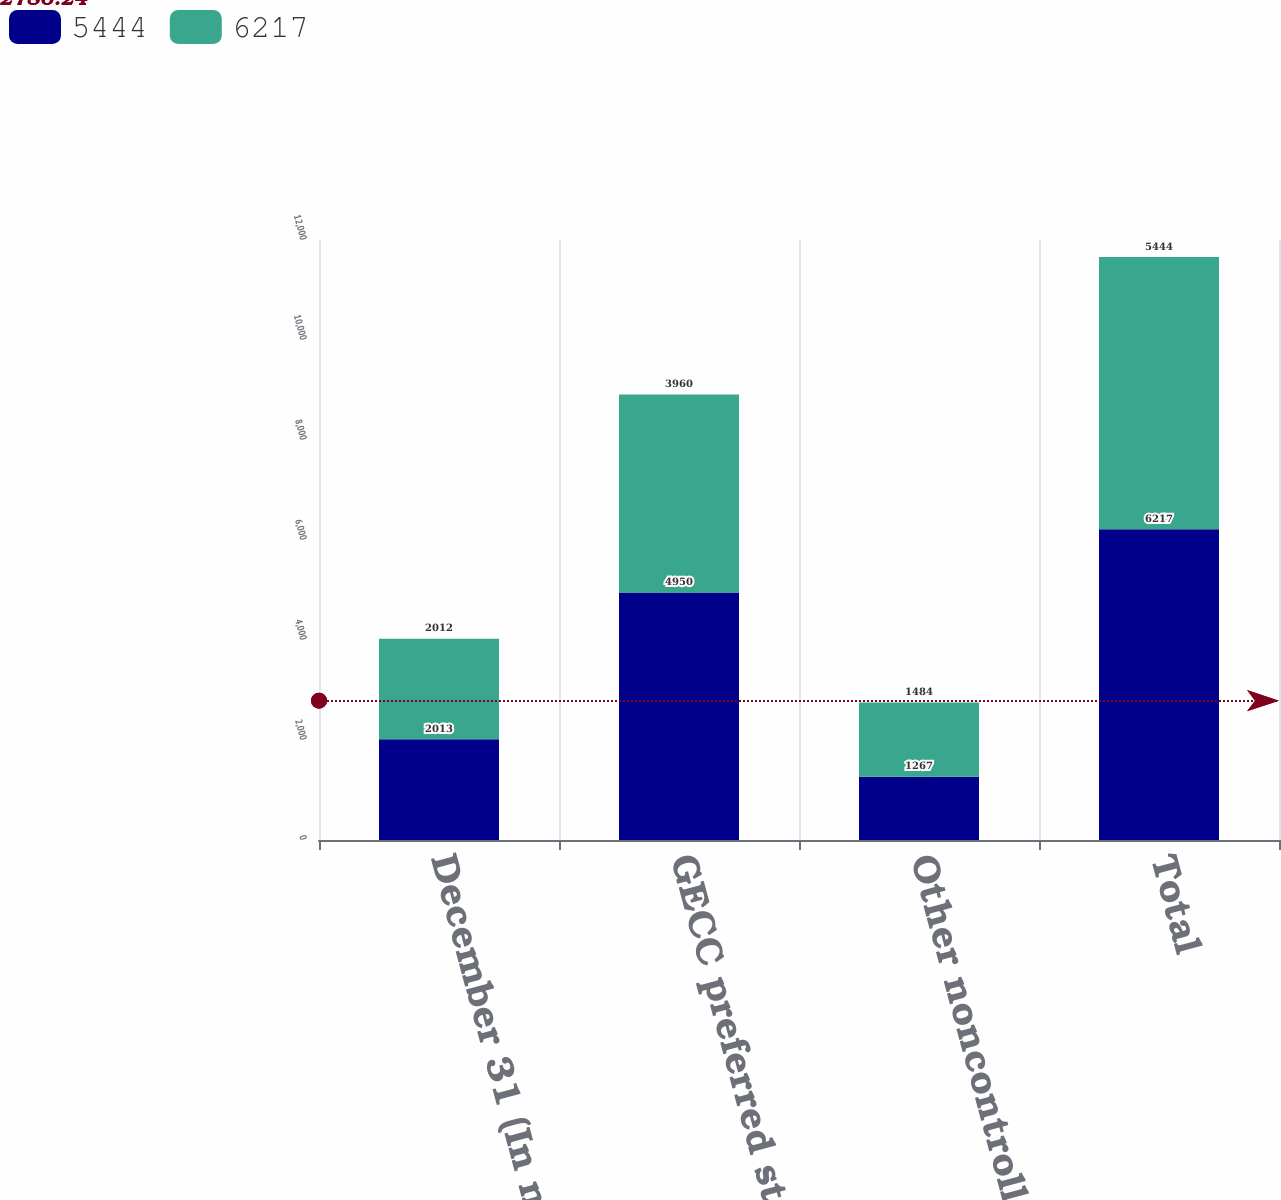<chart> <loc_0><loc_0><loc_500><loc_500><stacked_bar_chart><ecel><fcel>December 31 (In millions)<fcel>GECC preferred stock<fcel>Other noncontrolling interests<fcel>Total<nl><fcel>5444<fcel>2013<fcel>4950<fcel>1267<fcel>6217<nl><fcel>6217<fcel>2012<fcel>3960<fcel>1484<fcel>5444<nl></chart> 